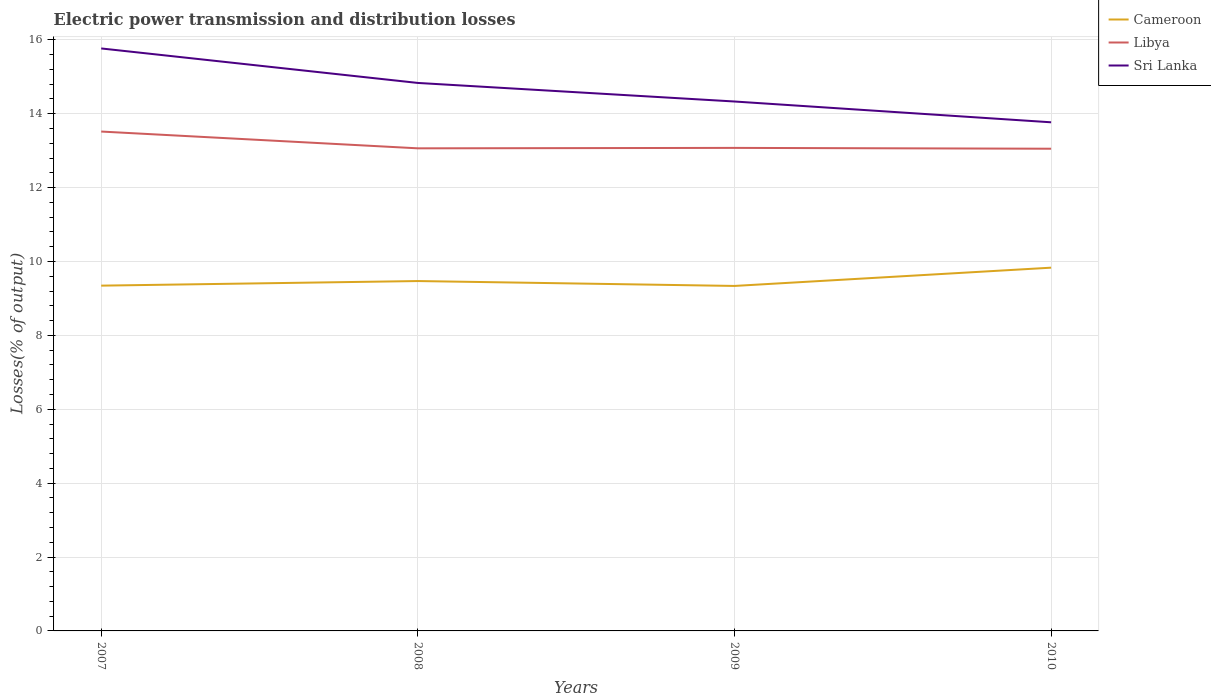Is the number of lines equal to the number of legend labels?
Offer a terse response. Yes. Across all years, what is the maximum electric power transmission and distribution losses in Cameroon?
Provide a short and direct response. 9.34. In which year was the electric power transmission and distribution losses in Libya maximum?
Your answer should be compact. 2010. What is the total electric power transmission and distribution losses in Sri Lanka in the graph?
Offer a very short reply. 0.5. What is the difference between the highest and the second highest electric power transmission and distribution losses in Libya?
Offer a terse response. 0.46. Is the electric power transmission and distribution losses in Libya strictly greater than the electric power transmission and distribution losses in Cameroon over the years?
Make the answer very short. No. Does the graph contain any zero values?
Your answer should be very brief. No. Does the graph contain grids?
Ensure brevity in your answer.  Yes. Where does the legend appear in the graph?
Keep it short and to the point. Top right. What is the title of the graph?
Your answer should be very brief. Electric power transmission and distribution losses. Does "Greenland" appear as one of the legend labels in the graph?
Give a very brief answer. No. What is the label or title of the X-axis?
Make the answer very short. Years. What is the label or title of the Y-axis?
Offer a terse response. Losses(% of output). What is the Losses(% of output) of Cameroon in 2007?
Provide a short and direct response. 9.35. What is the Losses(% of output) of Libya in 2007?
Your response must be concise. 13.52. What is the Losses(% of output) in Sri Lanka in 2007?
Offer a terse response. 15.77. What is the Losses(% of output) in Cameroon in 2008?
Give a very brief answer. 9.47. What is the Losses(% of output) of Libya in 2008?
Offer a terse response. 13.06. What is the Losses(% of output) of Sri Lanka in 2008?
Provide a short and direct response. 14.83. What is the Losses(% of output) in Cameroon in 2009?
Give a very brief answer. 9.34. What is the Losses(% of output) in Libya in 2009?
Ensure brevity in your answer.  13.07. What is the Losses(% of output) in Sri Lanka in 2009?
Ensure brevity in your answer.  14.33. What is the Losses(% of output) of Cameroon in 2010?
Your answer should be very brief. 9.83. What is the Losses(% of output) in Libya in 2010?
Your response must be concise. 13.05. What is the Losses(% of output) in Sri Lanka in 2010?
Your response must be concise. 13.77. Across all years, what is the maximum Losses(% of output) in Cameroon?
Offer a terse response. 9.83. Across all years, what is the maximum Losses(% of output) in Libya?
Your response must be concise. 13.52. Across all years, what is the maximum Losses(% of output) in Sri Lanka?
Your response must be concise. 15.77. Across all years, what is the minimum Losses(% of output) of Cameroon?
Your answer should be compact. 9.34. Across all years, what is the minimum Losses(% of output) of Libya?
Your response must be concise. 13.05. Across all years, what is the minimum Losses(% of output) in Sri Lanka?
Your answer should be very brief. 13.77. What is the total Losses(% of output) of Cameroon in the graph?
Offer a terse response. 37.99. What is the total Losses(% of output) in Libya in the graph?
Your answer should be compact. 52.71. What is the total Losses(% of output) in Sri Lanka in the graph?
Provide a short and direct response. 58.7. What is the difference between the Losses(% of output) of Cameroon in 2007 and that in 2008?
Your answer should be compact. -0.12. What is the difference between the Losses(% of output) in Libya in 2007 and that in 2008?
Ensure brevity in your answer.  0.45. What is the difference between the Losses(% of output) of Sri Lanka in 2007 and that in 2008?
Provide a succinct answer. 0.93. What is the difference between the Losses(% of output) of Cameroon in 2007 and that in 2009?
Make the answer very short. 0.01. What is the difference between the Losses(% of output) of Libya in 2007 and that in 2009?
Provide a short and direct response. 0.44. What is the difference between the Losses(% of output) of Sri Lanka in 2007 and that in 2009?
Give a very brief answer. 1.44. What is the difference between the Losses(% of output) in Cameroon in 2007 and that in 2010?
Your answer should be very brief. -0.49. What is the difference between the Losses(% of output) in Libya in 2007 and that in 2010?
Your response must be concise. 0.46. What is the difference between the Losses(% of output) of Sri Lanka in 2007 and that in 2010?
Give a very brief answer. 2. What is the difference between the Losses(% of output) in Cameroon in 2008 and that in 2009?
Keep it short and to the point. 0.13. What is the difference between the Losses(% of output) of Libya in 2008 and that in 2009?
Give a very brief answer. -0.01. What is the difference between the Losses(% of output) of Sri Lanka in 2008 and that in 2009?
Provide a succinct answer. 0.5. What is the difference between the Losses(% of output) in Cameroon in 2008 and that in 2010?
Offer a very short reply. -0.36. What is the difference between the Losses(% of output) in Libya in 2008 and that in 2010?
Your answer should be compact. 0.01. What is the difference between the Losses(% of output) of Sri Lanka in 2008 and that in 2010?
Your answer should be compact. 1.07. What is the difference between the Losses(% of output) of Cameroon in 2009 and that in 2010?
Make the answer very short. -0.49. What is the difference between the Losses(% of output) in Libya in 2009 and that in 2010?
Keep it short and to the point. 0.02. What is the difference between the Losses(% of output) in Sri Lanka in 2009 and that in 2010?
Your response must be concise. 0.56. What is the difference between the Losses(% of output) in Cameroon in 2007 and the Losses(% of output) in Libya in 2008?
Offer a terse response. -3.72. What is the difference between the Losses(% of output) of Cameroon in 2007 and the Losses(% of output) of Sri Lanka in 2008?
Your response must be concise. -5.49. What is the difference between the Losses(% of output) in Libya in 2007 and the Losses(% of output) in Sri Lanka in 2008?
Provide a succinct answer. -1.32. What is the difference between the Losses(% of output) of Cameroon in 2007 and the Losses(% of output) of Libya in 2009?
Provide a succinct answer. -3.73. What is the difference between the Losses(% of output) in Cameroon in 2007 and the Losses(% of output) in Sri Lanka in 2009?
Make the answer very short. -4.98. What is the difference between the Losses(% of output) in Libya in 2007 and the Losses(% of output) in Sri Lanka in 2009?
Give a very brief answer. -0.81. What is the difference between the Losses(% of output) in Cameroon in 2007 and the Losses(% of output) in Libya in 2010?
Offer a very short reply. -3.71. What is the difference between the Losses(% of output) in Cameroon in 2007 and the Losses(% of output) in Sri Lanka in 2010?
Make the answer very short. -4.42. What is the difference between the Losses(% of output) in Libya in 2007 and the Losses(% of output) in Sri Lanka in 2010?
Your answer should be very brief. -0.25. What is the difference between the Losses(% of output) in Cameroon in 2008 and the Losses(% of output) in Libya in 2009?
Provide a short and direct response. -3.6. What is the difference between the Losses(% of output) of Cameroon in 2008 and the Losses(% of output) of Sri Lanka in 2009?
Provide a succinct answer. -4.86. What is the difference between the Losses(% of output) of Libya in 2008 and the Losses(% of output) of Sri Lanka in 2009?
Your response must be concise. -1.27. What is the difference between the Losses(% of output) of Cameroon in 2008 and the Losses(% of output) of Libya in 2010?
Make the answer very short. -3.58. What is the difference between the Losses(% of output) in Cameroon in 2008 and the Losses(% of output) in Sri Lanka in 2010?
Give a very brief answer. -4.3. What is the difference between the Losses(% of output) of Libya in 2008 and the Losses(% of output) of Sri Lanka in 2010?
Your answer should be compact. -0.7. What is the difference between the Losses(% of output) in Cameroon in 2009 and the Losses(% of output) in Libya in 2010?
Give a very brief answer. -3.71. What is the difference between the Losses(% of output) of Cameroon in 2009 and the Losses(% of output) of Sri Lanka in 2010?
Ensure brevity in your answer.  -4.43. What is the difference between the Losses(% of output) of Libya in 2009 and the Losses(% of output) of Sri Lanka in 2010?
Your answer should be compact. -0.69. What is the average Losses(% of output) in Cameroon per year?
Make the answer very short. 9.5. What is the average Losses(% of output) in Libya per year?
Provide a short and direct response. 13.18. What is the average Losses(% of output) of Sri Lanka per year?
Offer a very short reply. 14.67. In the year 2007, what is the difference between the Losses(% of output) in Cameroon and Losses(% of output) in Libya?
Give a very brief answer. -4.17. In the year 2007, what is the difference between the Losses(% of output) in Cameroon and Losses(% of output) in Sri Lanka?
Your answer should be very brief. -6.42. In the year 2007, what is the difference between the Losses(% of output) in Libya and Losses(% of output) in Sri Lanka?
Your response must be concise. -2.25. In the year 2008, what is the difference between the Losses(% of output) in Cameroon and Losses(% of output) in Libya?
Provide a short and direct response. -3.59. In the year 2008, what is the difference between the Losses(% of output) of Cameroon and Losses(% of output) of Sri Lanka?
Your answer should be very brief. -5.36. In the year 2008, what is the difference between the Losses(% of output) in Libya and Losses(% of output) in Sri Lanka?
Offer a very short reply. -1.77. In the year 2009, what is the difference between the Losses(% of output) in Cameroon and Losses(% of output) in Libya?
Your answer should be very brief. -3.74. In the year 2009, what is the difference between the Losses(% of output) of Cameroon and Losses(% of output) of Sri Lanka?
Your answer should be very brief. -4.99. In the year 2009, what is the difference between the Losses(% of output) of Libya and Losses(% of output) of Sri Lanka?
Your answer should be compact. -1.26. In the year 2010, what is the difference between the Losses(% of output) of Cameroon and Losses(% of output) of Libya?
Your answer should be very brief. -3.22. In the year 2010, what is the difference between the Losses(% of output) of Cameroon and Losses(% of output) of Sri Lanka?
Make the answer very short. -3.94. In the year 2010, what is the difference between the Losses(% of output) in Libya and Losses(% of output) in Sri Lanka?
Provide a short and direct response. -0.71. What is the ratio of the Losses(% of output) in Cameroon in 2007 to that in 2008?
Provide a succinct answer. 0.99. What is the ratio of the Losses(% of output) in Libya in 2007 to that in 2008?
Make the answer very short. 1.03. What is the ratio of the Losses(% of output) in Sri Lanka in 2007 to that in 2008?
Offer a very short reply. 1.06. What is the ratio of the Losses(% of output) in Cameroon in 2007 to that in 2009?
Provide a succinct answer. 1. What is the ratio of the Losses(% of output) of Libya in 2007 to that in 2009?
Offer a very short reply. 1.03. What is the ratio of the Losses(% of output) in Sri Lanka in 2007 to that in 2009?
Offer a terse response. 1.1. What is the ratio of the Losses(% of output) of Cameroon in 2007 to that in 2010?
Your answer should be compact. 0.95. What is the ratio of the Losses(% of output) in Libya in 2007 to that in 2010?
Offer a terse response. 1.04. What is the ratio of the Losses(% of output) in Sri Lanka in 2007 to that in 2010?
Offer a very short reply. 1.15. What is the ratio of the Losses(% of output) of Cameroon in 2008 to that in 2009?
Provide a succinct answer. 1.01. What is the ratio of the Losses(% of output) in Libya in 2008 to that in 2009?
Make the answer very short. 1. What is the ratio of the Losses(% of output) in Sri Lanka in 2008 to that in 2009?
Provide a short and direct response. 1.04. What is the ratio of the Losses(% of output) of Cameroon in 2008 to that in 2010?
Ensure brevity in your answer.  0.96. What is the ratio of the Losses(% of output) of Libya in 2008 to that in 2010?
Provide a short and direct response. 1. What is the ratio of the Losses(% of output) in Sri Lanka in 2008 to that in 2010?
Ensure brevity in your answer.  1.08. What is the ratio of the Losses(% of output) of Cameroon in 2009 to that in 2010?
Your response must be concise. 0.95. What is the ratio of the Losses(% of output) in Sri Lanka in 2009 to that in 2010?
Your response must be concise. 1.04. What is the difference between the highest and the second highest Losses(% of output) of Cameroon?
Offer a very short reply. 0.36. What is the difference between the highest and the second highest Losses(% of output) of Libya?
Provide a succinct answer. 0.44. What is the difference between the highest and the second highest Losses(% of output) in Sri Lanka?
Provide a short and direct response. 0.93. What is the difference between the highest and the lowest Losses(% of output) of Cameroon?
Give a very brief answer. 0.49. What is the difference between the highest and the lowest Losses(% of output) of Libya?
Give a very brief answer. 0.46. What is the difference between the highest and the lowest Losses(% of output) in Sri Lanka?
Give a very brief answer. 2. 